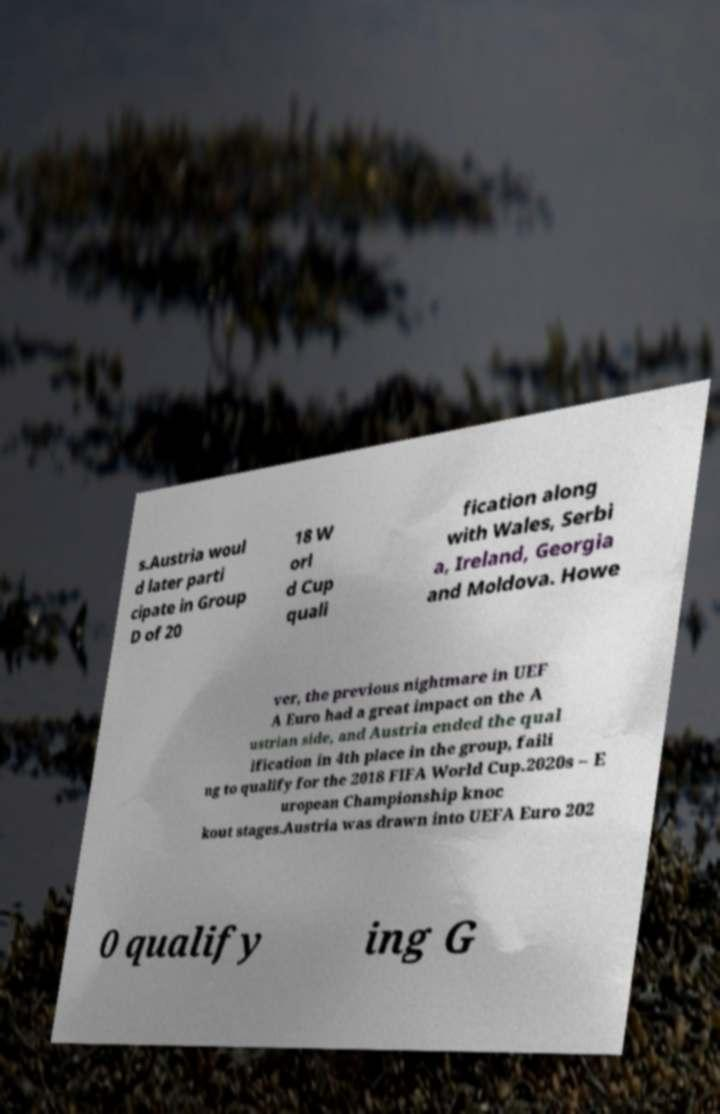What messages or text are displayed in this image? I need them in a readable, typed format. s.Austria woul d later parti cipate in Group D of 20 18 W orl d Cup quali fication along with Wales, Serbi a, Ireland, Georgia and Moldova. Howe ver, the previous nightmare in UEF A Euro had a great impact on the A ustrian side, and Austria ended the qual ification in 4th place in the group, faili ng to qualify for the 2018 FIFA World Cup.2020s – E uropean Championship knoc kout stages.Austria was drawn into UEFA Euro 202 0 qualify ing G 